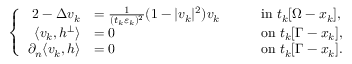<formula> <loc_0><loc_0><loc_500><loc_500>\left \{ \begin{array} { r l r l } { { 2 } - \Delta v _ { k } } & { = \frac { 1 } { ( t _ { k } \varepsilon _ { k } ) ^ { 2 } } ( 1 - | v _ { k } | ^ { 2 } ) v _ { k } \quad } & & { i n \ t _ { k } [ \Omega - x _ { k } ] , } \\ { \langle v _ { k } , h ^ { \perp } \rangle } & { = 0 \quad } & & { o n \ t _ { k } [ \Gamma - x _ { k } ] , } \\ { \partial _ { n } \langle v _ { k } , h \rangle } & { = 0 \quad } & & { o n \ t _ { k } [ \Gamma - x _ { k } ] . } \end{array}</formula> 